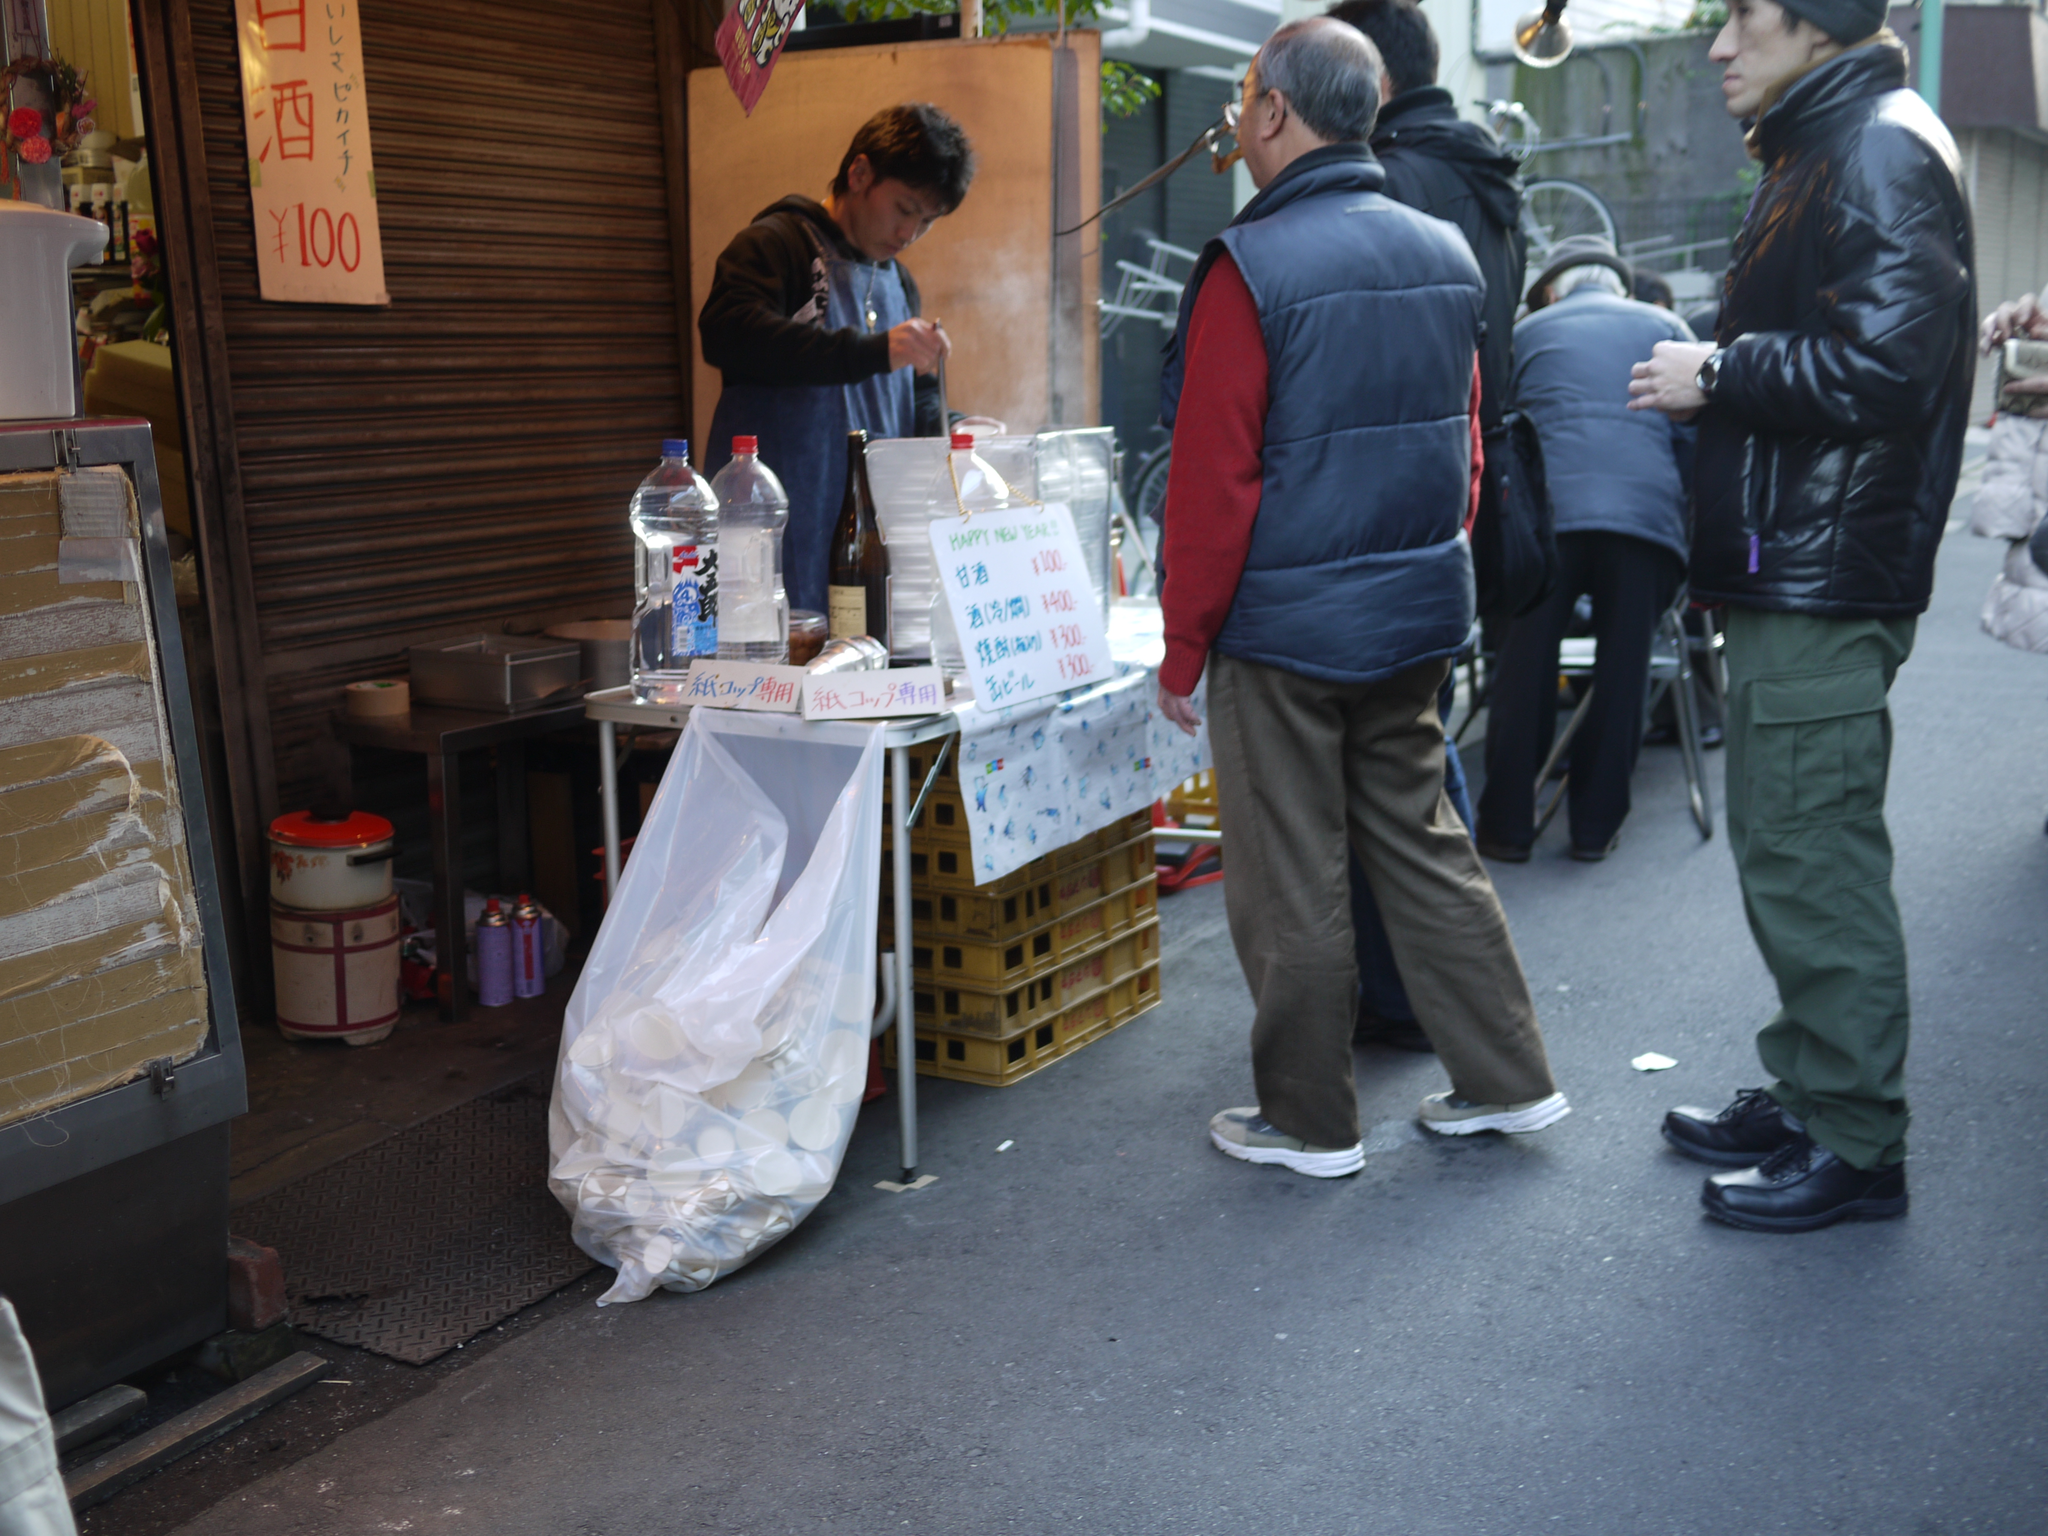Could you give a brief overview of what you see in this image? This is a picture taken in outdoor, There are group of people standing on the road. The man in blue jacket in front of the man there is a table on the table there are bottle and a board. Background of this people there is a shatter and a banner. 